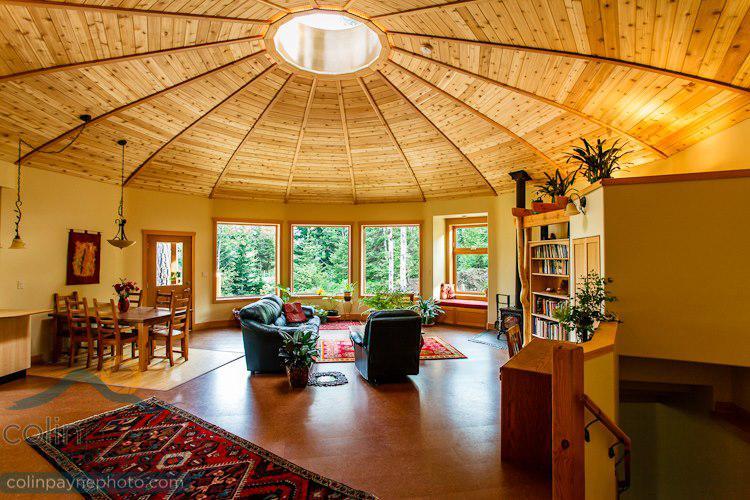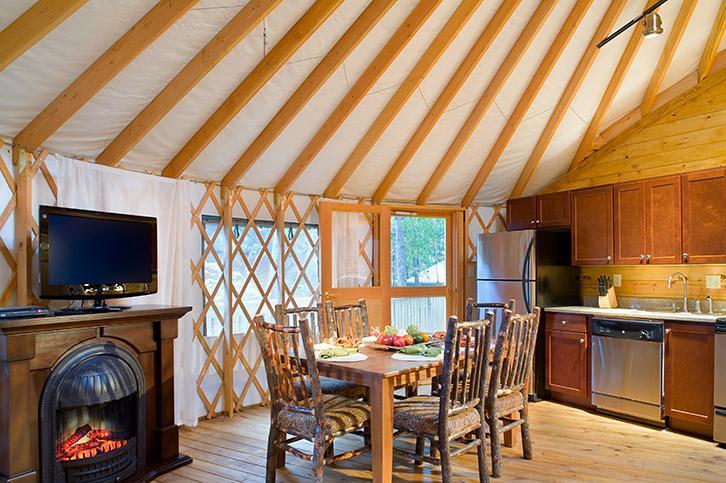The first image is the image on the left, the second image is the image on the right. Analyze the images presented: Is the assertion "In the right image there is a staircase on the left leading up right towards the center." valid? Answer yes or no. No. 